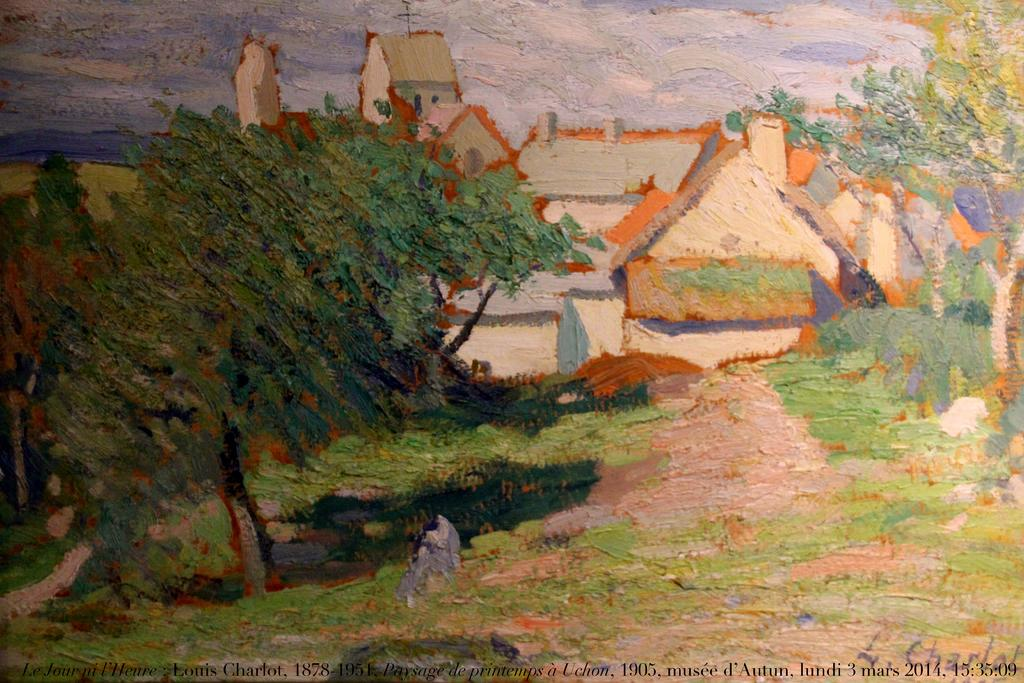What is depicted on the paper in the image? There is a painting on the paper in the image. What type of structures can be seen in the image? There are houses in the image. What type of vegetation is present in the image? There are trees and plants on the ground in the image. What is visible in the background of the image? There is a sky visible in the image, with clouds present. How many boys are playing with the cats in the image? There are no boys or cats present in the image. What type of advice does the minister offer in the image? There is no minister present in the image, so no advice can be given. 